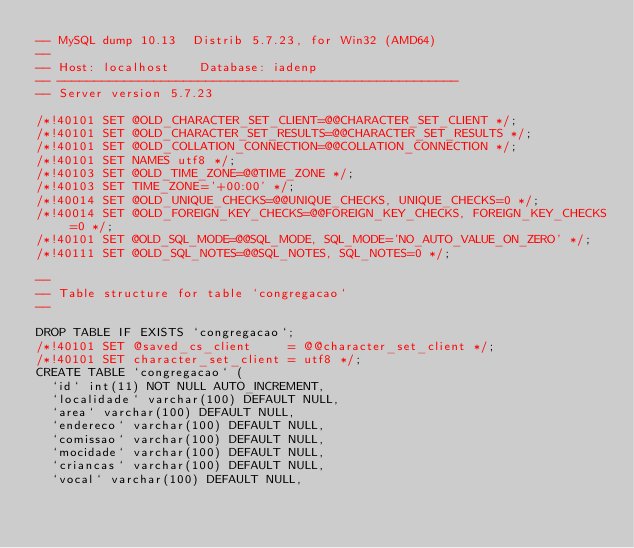<code> <loc_0><loc_0><loc_500><loc_500><_SQL_>-- MySQL dump 10.13  Distrib 5.7.23, for Win32 (AMD64)
--
-- Host: localhost    Database: iadenp
-- ------------------------------------------------------
-- Server version	5.7.23

/*!40101 SET @OLD_CHARACTER_SET_CLIENT=@@CHARACTER_SET_CLIENT */;
/*!40101 SET @OLD_CHARACTER_SET_RESULTS=@@CHARACTER_SET_RESULTS */;
/*!40101 SET @OLD_COLLATION_CONNECTION=@@COLLATION_CONNECTION */;
/*!40101 SET NAMES utf8 */;
/*!40103 SET @OLD_TIME_ZONE=@@TIME_ZONE */;
/*!40103 SET TIME_ZONE='+00:00' */;
/*!40014 SET @OLD_UNIQUE_CHECKS=@@UNIQUE_CHECKS, UNIQUE_CHECKS=0 */;
/*!40014 SET @OLD_FOREIGN_KEY_CHECKS=@@FOREIGN_KEY_CHECKS, FOREIGN_KEY_CHECKS=0 */;
/*!40101 SET @OLD_SQL_MODE=@@SQL_MODE, SQL_MODE='NO_AUTO_VALUE_ON_ZERO' */;
/*!40111 SET @OLD_SQL_NOTES=@@SQL_NOTES, SQL_NOTES=0 */;

--
-- Table structure for table `congregacao`
--

DROP TABLE IF EXISTS `congregacao`;
/*!40101 SET @saved_cs_client     = @@character_set_client */;
/*!40101 SET character_set_client = utf8 */;
CREATE TABLE `congregacao` (
  `id` int(11) NOT NULL AUTO_INCREMENT,
  `localidade` varchar(100) DEFAULT NULL,
  `area` varchar(100) DEFAULT NULL,
  `endereco` varchar(100) DEFAULT NULL,
  `comissao` varchar(100) DEFAULT NULL,
  `mocidade` varchar(100) DEFAULT NULL,
  `criancas` varchar(100) DEFAULT NULL,
  `vocal` varchar(100) DEFAULT NULL,</code> 